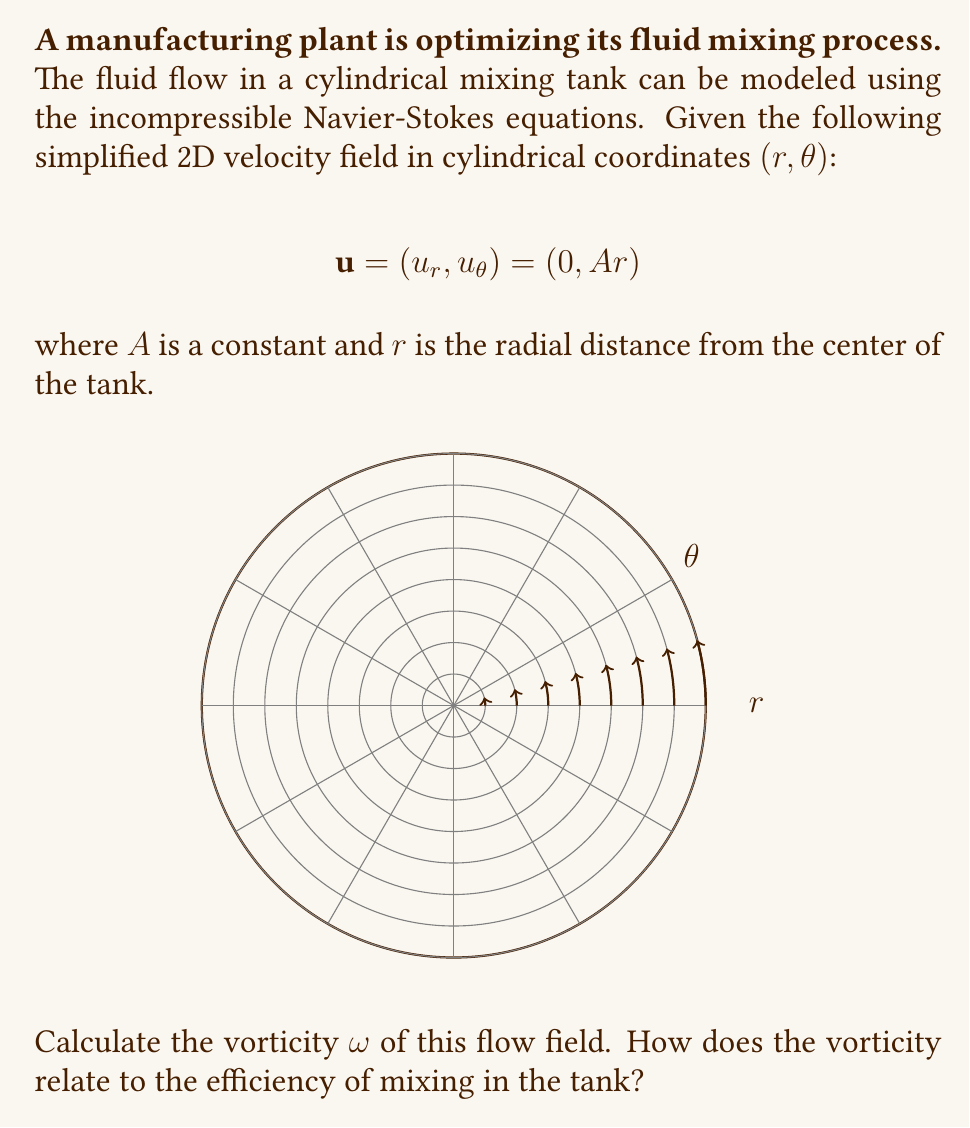Could you help me with this problem? Let's approach this step-by-step:

1) The vorticity in cylindrical coordinates is given by:

   $$\omega = \frac{1}{r}\frac{\partial}{\partial r}(ru_\theta) - \frac{1}{r}\frac{\partial u_r}{\partial \theta}$$

2) We're given that $u_r = 0$ and $u_\theta = Ar$. Let's substitute these into the vorticity equation:

   $$\omega = \frac{1}{r}\frac{\partial}{\partial r}(r(Ar)) - \frac{1}{r}\frac{\partial}{\partial \theta}(0)$$

3) Simplify the first term:

   $$\omega = \frac{1}{r}\frac{\partial}{\partial r}(Ar^2) - 0$$

4) Apply the chain rule:

   $$\omega = \frac{1}{r}(2Ar) = 2A$$

5) Therefore, the vorticity is constant throughout the flow field and equal to $2A$.

Regarding efficiency:
- A non-zero vorticity indicates rotation in the fluid, which is crucial for mixing.
- The constant vorticity suggests uniform mixing throughout the tank, which is generally desirable for efficiency.
- However, the optimal vorticity depends on the specific fluid properties and mixing requirements.
- Too low vorticity may result in insufficient mixing, while too high vorticity might consume excessive energy or cause unwanted effects like cavitation.
- The constant $A$ can be adjusted to optimize the mixing process based on experimental data or more detailed simulations.
Answer: $\omega = 2A$ 